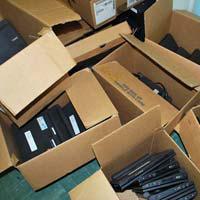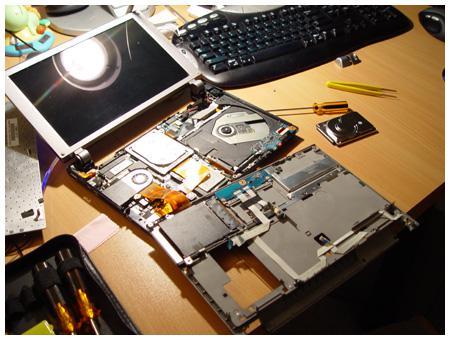The first image is the image on the left, the second image is the image on the right. Evaluate the accuracy of this statement regarding the images: "In the image to the left, the electronics are in boxes.". Is it true? Answer yes or no. Yes. 